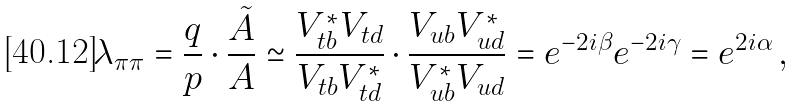<formula> <loc_0><loc_0><loc_500><loc_500>\lambda _ { \pi \pi } = \frac { q } { p } \cdot \frac { \tilde { A } } { A } \simeq \frac { V ^ { * } _ { t b } V _ { t d } } { V _ { t b } V ^ { * } _ { t d } } \cdot \frac { V _ { u b } V ^ { * } _ { u d } } { V ^ { * } _ { u b } V _ { u d } } = e ^ { - 2 i \beta } e ^ { - 2 i \gamma } = e ^ { 2 i \alpha } \, ,</formula> 